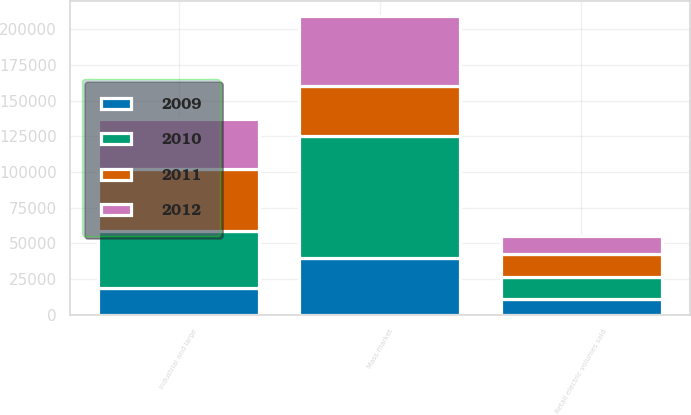Convert chart to OTSL. <chart><loc_0><loc_0><loc_500><loc_500><stacked_bar_chart><ecel><fcel>Retail electric volumes sold<fcel>Industrial and large<fcel>Mass market<nl><fcel>2009<fcel>10749<fcel>18828<fcel>39976<nl><fcel>2012<fcel>12723<fcel>35056<fcel>49094<nl><fcel>2010<fcel>15993<fcel>40081<fcel>85191<nl><fcel>2011<fcel>15725<fcel>42983<fcel>35056<nl></chart> 